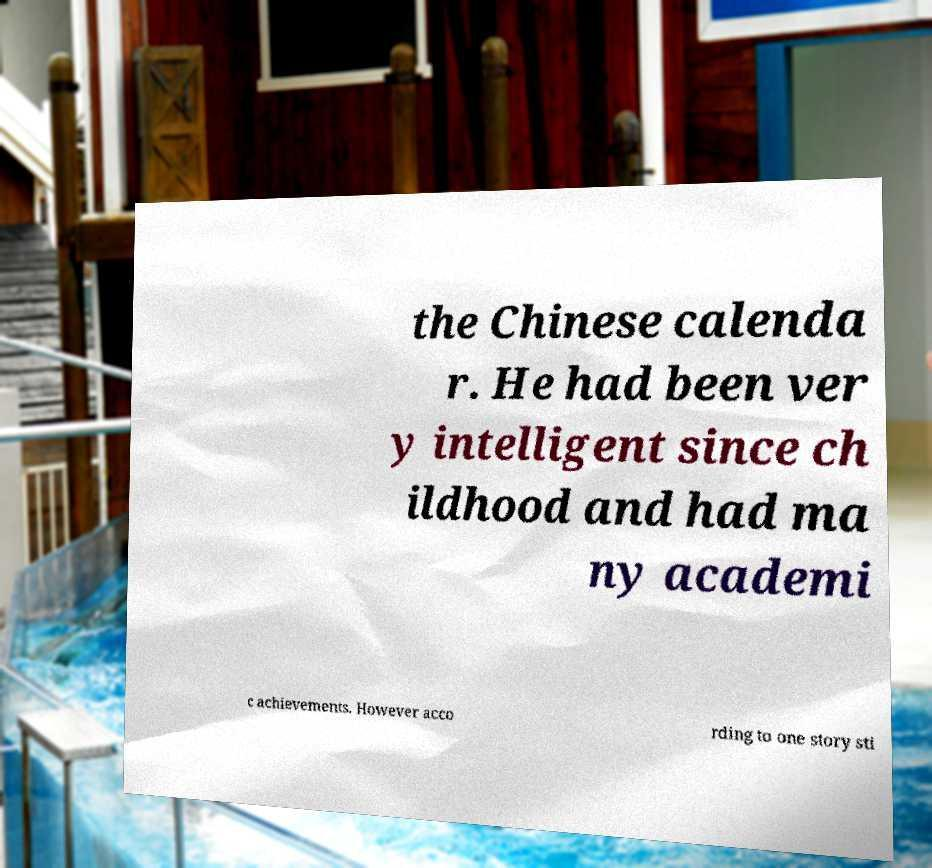Please identify and transcribe the text found in this image. the Chinese calenda r. He had been ver y intelligent since ch ildhood and had ma ny academi c achievements. However acco rding to one story sti 